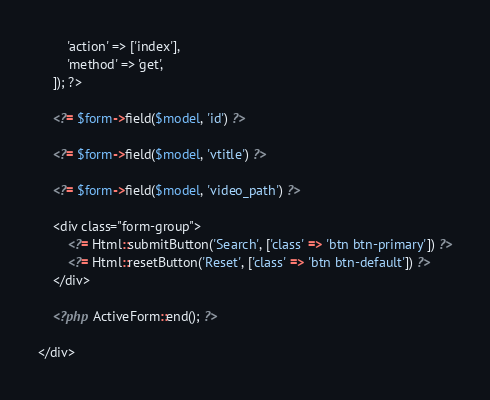Convert code to text. <code><loc_0><loc_0><loc_500><loc_500><_PHP_>        'action' => ['index'],
        'method' => 'get',
    ]); ?>

    <?= $form->field($model, 'id') ?>

    <?= $form->field($model, 'vtitle') ?>

    <?= $form->field($model, 'video_path') ?>

    <div class="form-group">
        <?= Html::submitButton('Search', ['class' => 'btn btn-primary']) ?>
        <?= Html::resetButton('Reset', ['class' => 'btn btn-default']) ?>
    </div>

    <?php ActiveForm::end(); ?>

</div>
</code> 